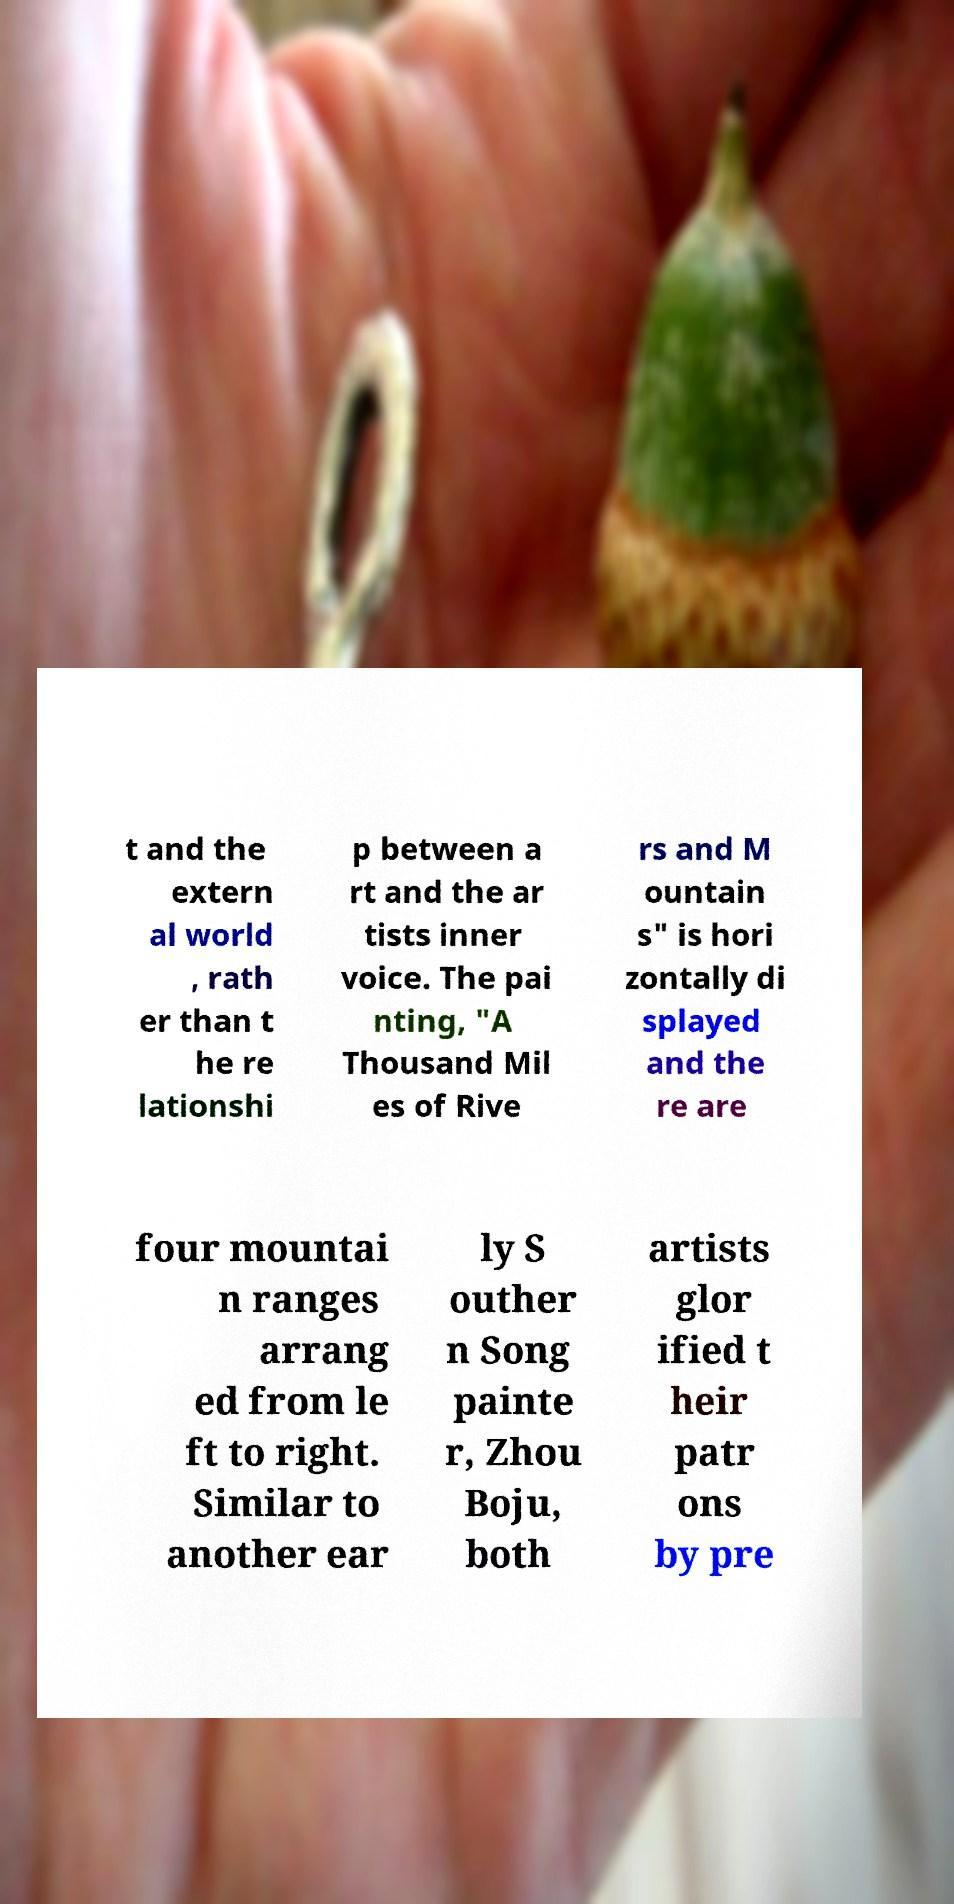For documentation purposes, I need the text within this image transcribed. Could you provide that? t and the extern al world , rath er than t he re lationshi p between a rt and the ar tists inner voice. The pai nting, "A Thousand Mil es of Rive rs and M ountain s" is hori zontally di splayed and the re are four mountai n ranges arrang ed from le ft to right. Similar to another ear ly S outher n Song painte r, Zhou Boju, both artists glor ified t heir patr ons by pre 